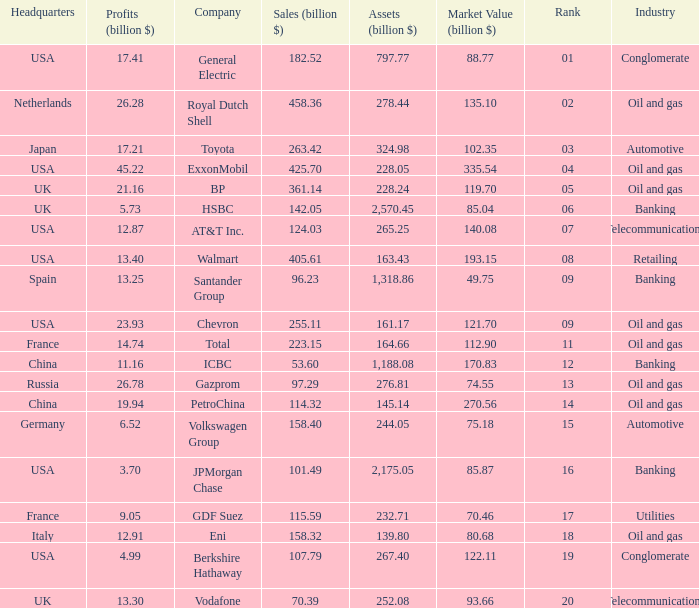How many Assets (billion $) has an Industry of oil and gas, and a Rank of 9, and a Market Value (billion $) larger than 121.7? None. 